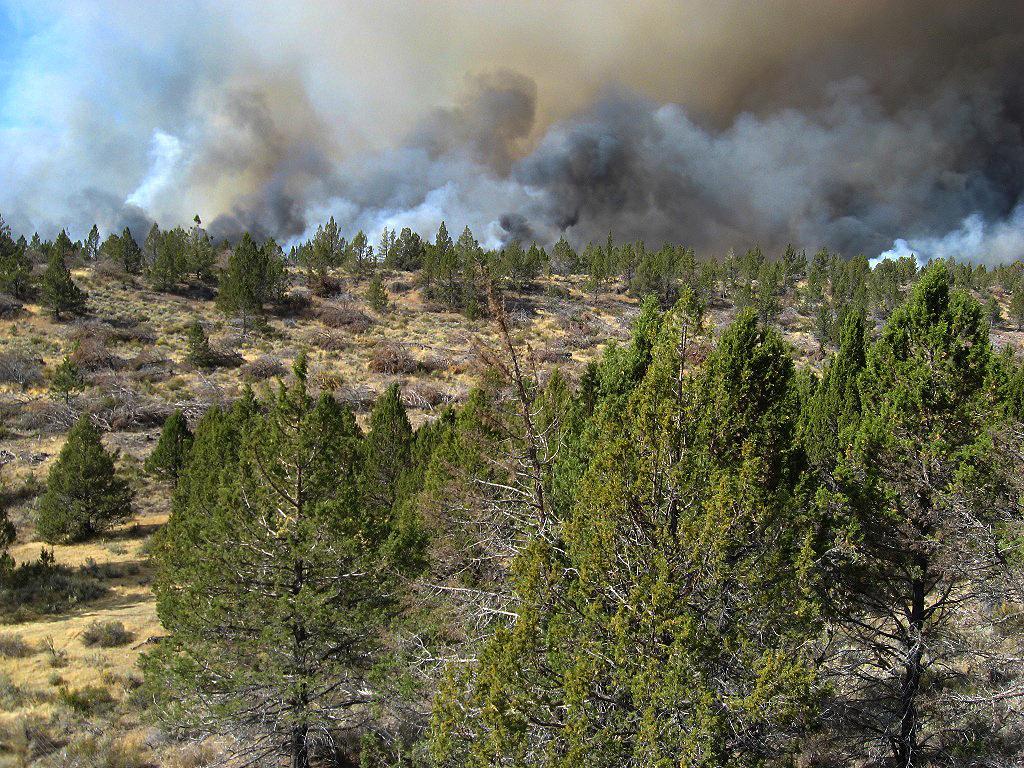Describe this image in one or two sentences. In this picture we can see so many trees and clouded sky. 